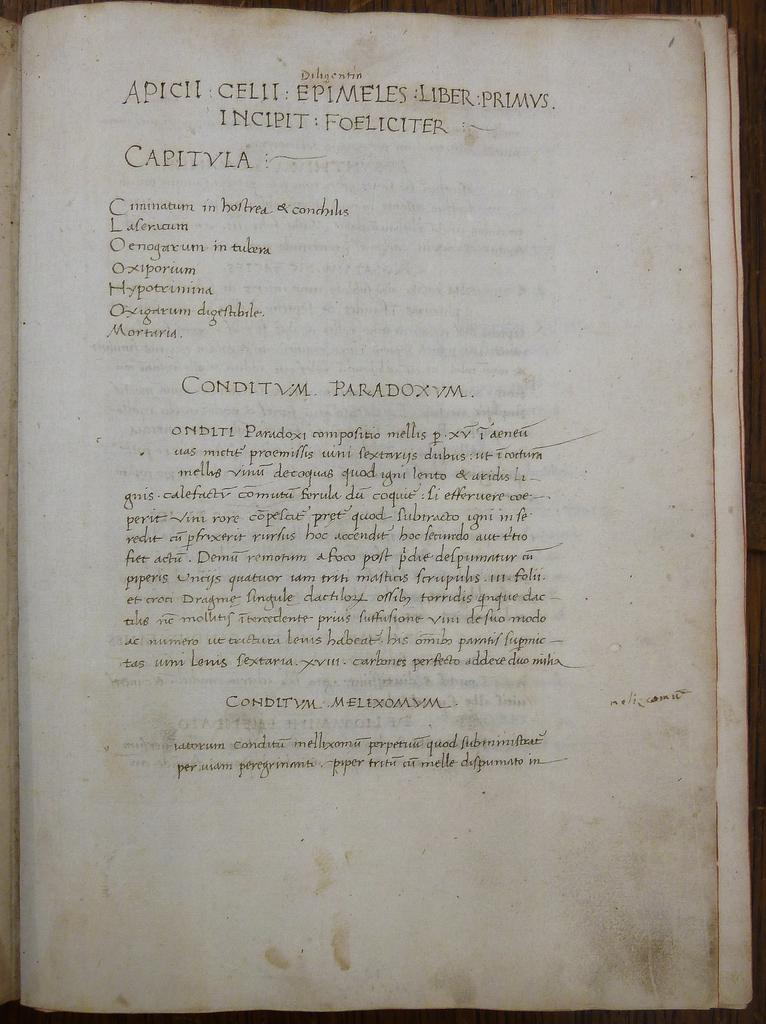<image>
Offer a succinct explanation of the picture presented. An old recipe book calls for ingredients such as Laleraum and Hypotrimina 